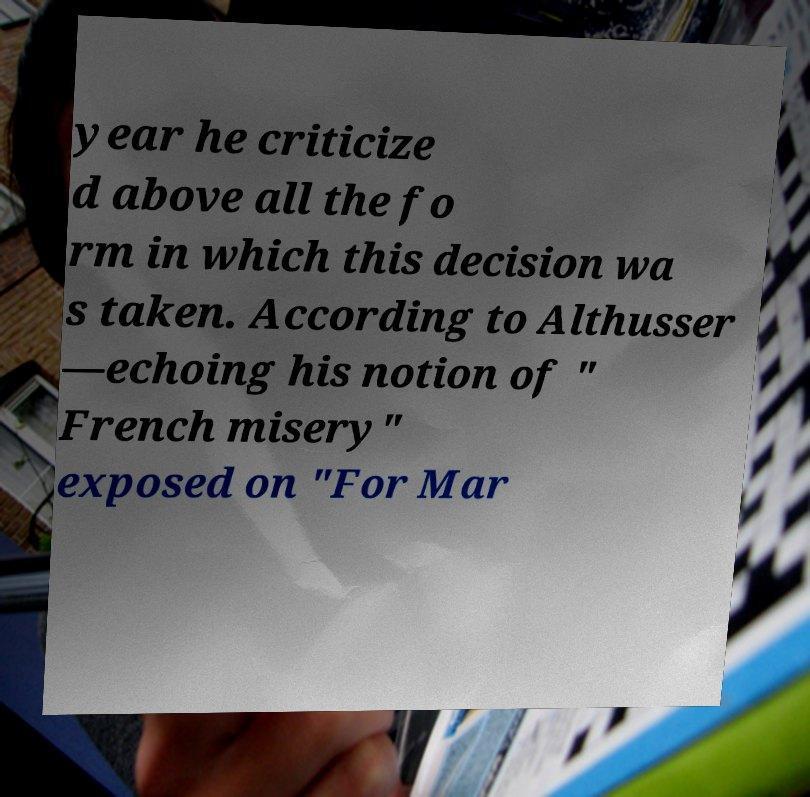Could you extract and type out the text from this image? year he criticize d above all the fo rm in which this decision wa s taken. According to Althusser —echoing his notion of " French misery" exposed on "For Mar 